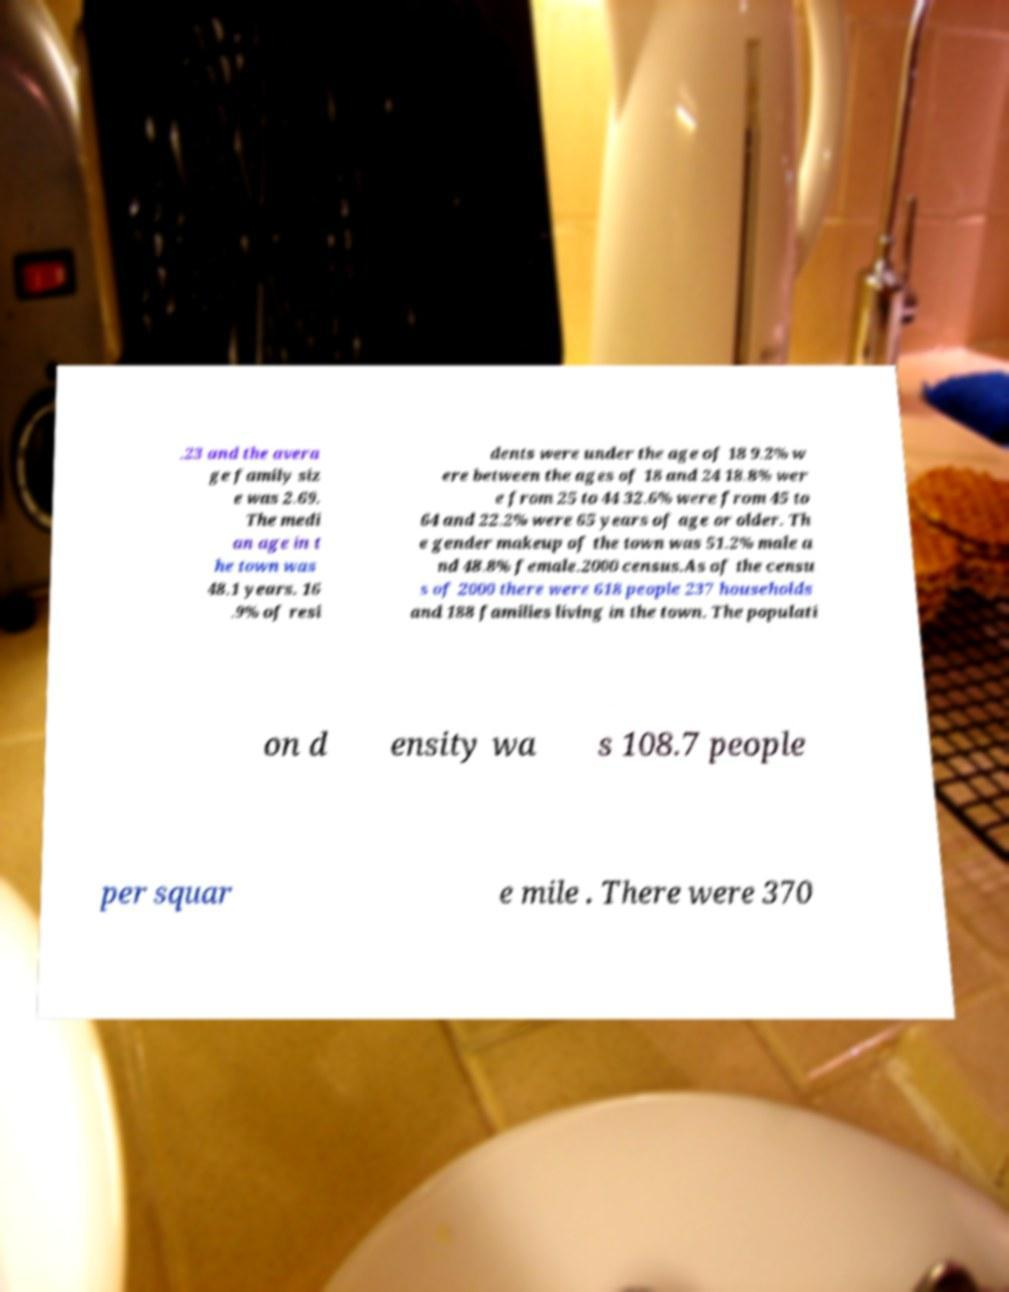Can you read and provide the text displayed in the image?This photo seems to have some interesting text. Can you extract and type it out for me? .23 and the avera ge family siz e was 2.69. The medi an age in t he town was 48.1 years. 16 .9% of resi dents were under the age of 18 9.2% w ere between the ages of 18 and 24 18.8% wer e from 25 to 44 32.6% were from 45 to 64 and 22.2% were 65 years of age or older. Th e gender makeup of the town was 51.2% male a nd 48.8% female.2000 census.As of the censu s of 2000 there were 618 people 237 households and 188 families living in the town. The populati on d ensity wa s 108.7 people per squar e mile . There were 370 